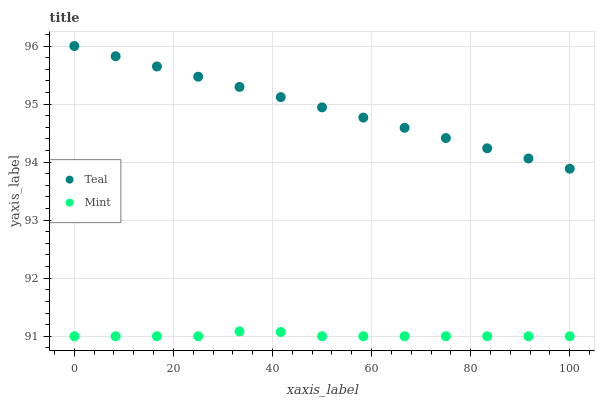Does Mint have the minimum area under the curve?
Answer yes or no. Yes. Does Teal have the maximum area under the curve?
Answer yes or no. Yes. Does Teal have the minimum area under the curve?
Answer yes or no. No. Is Teal the smoothest?
Answer yes or no. Yes. Is Mint the roughest?
Answer yes or no. Yes. Is Teal the roughest?
Answer yes or no. No. Does Mint have the lowest value?
Answer yes or no. Yes. Does Teal have the lowest value?
Answer yes or no. No. Does Teal have the highest value?
Answer yes or no. Yes. Is Mint less than Teal?
Answer yes or no. Yes. Is Teal greater than Mint?
Answer yes or no. Yes. Does Mint intersect Teal?
Answer yes or no. No. 